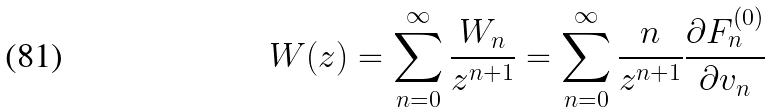Convert formula to latex. <formula><loc_0><loc_0><loc_500><loc_500>W ( z ) = \sum _ { n = 0 } ^ { \infty } \frac { W _ { n } } { z ^ { n + 1 } } = \sum _ { n = 0 } ^ { \infty } \frac { n } { z ^ { n + 1 } } \frac { \partial F _ { n } ^ { ( 0 ) } } { \partial v _ { n } }</formula> 